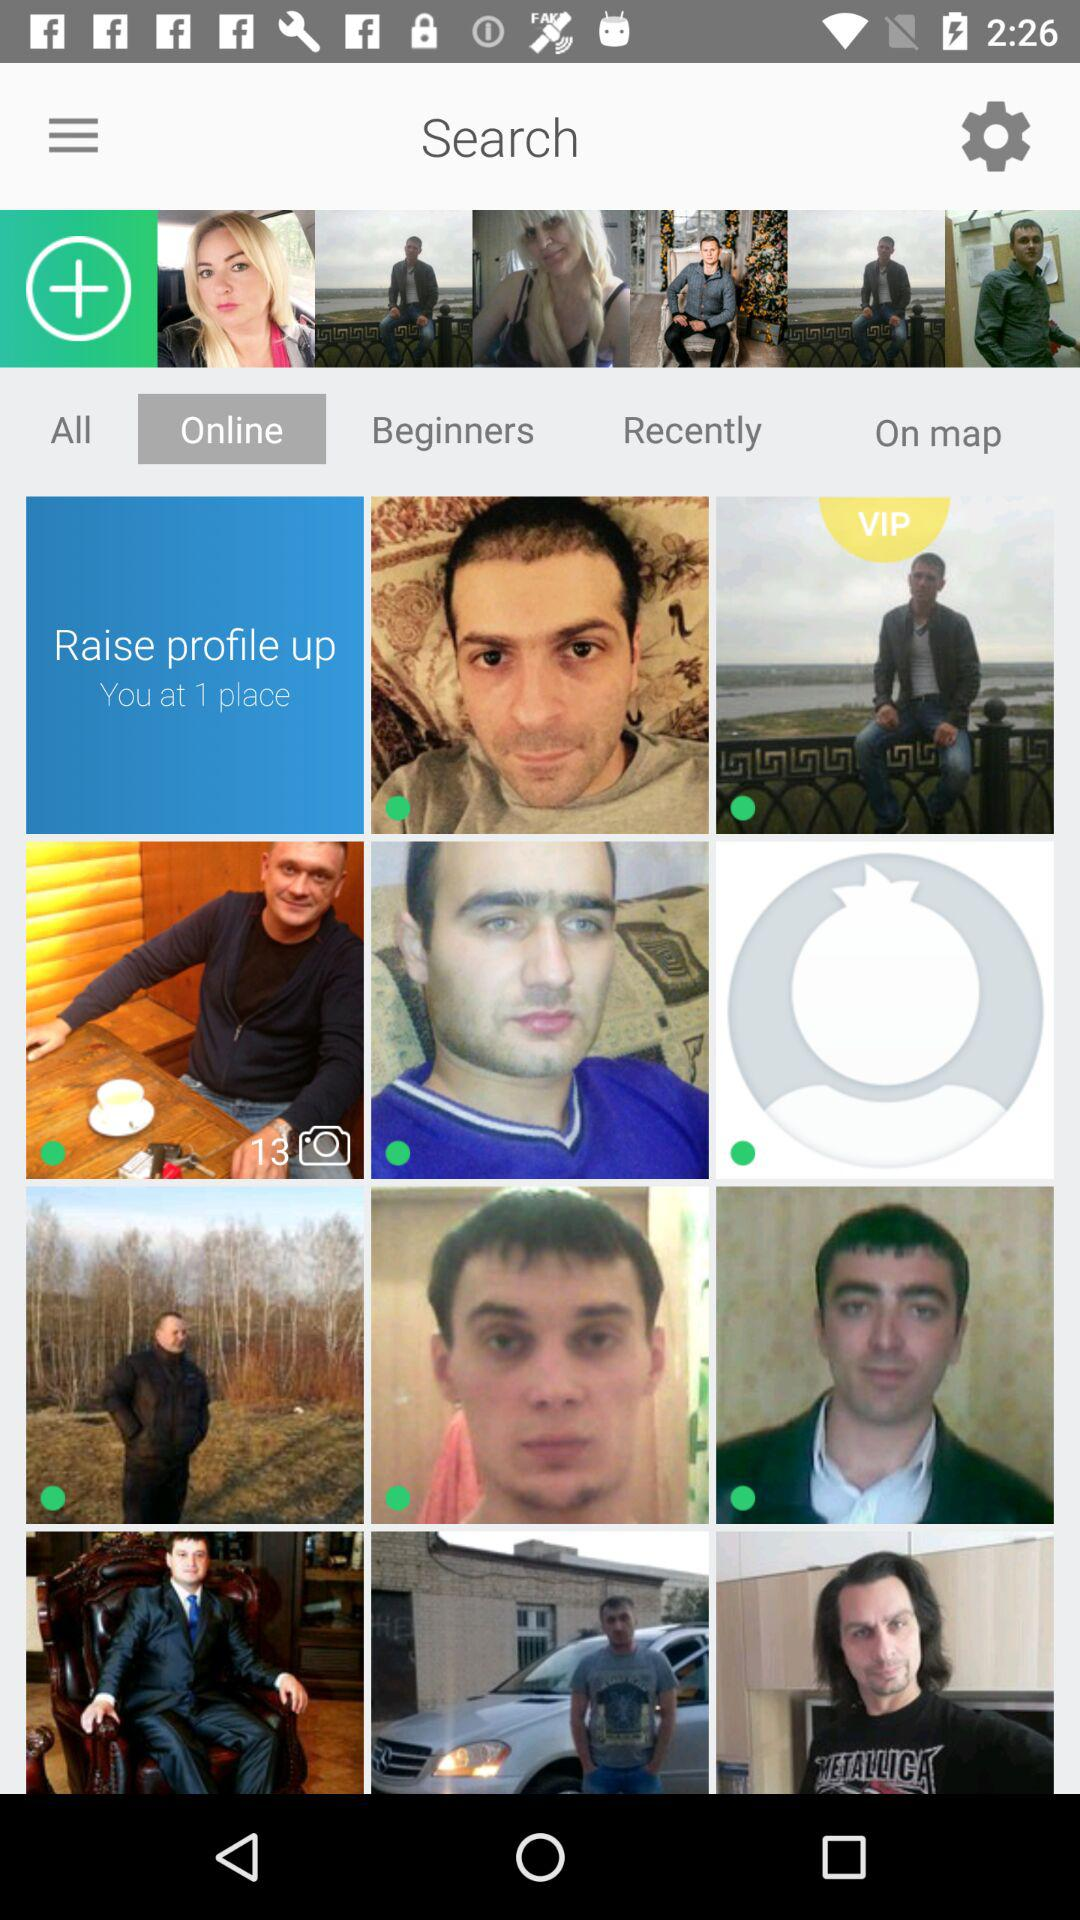What tab is selected? The selected tab is "Online". 